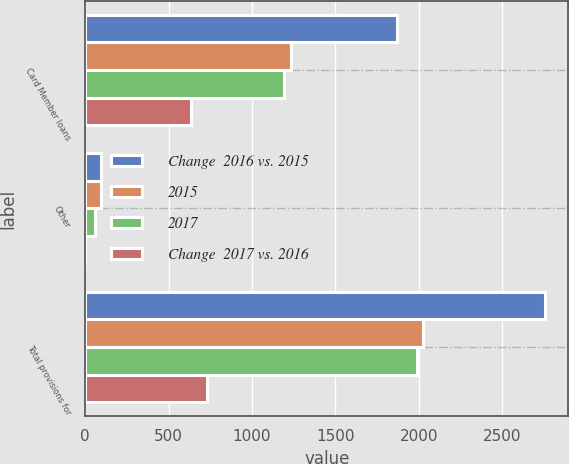<chart> <loc_0><loc_0><loc_500><loc_500><stacked_bar_chart><ecel><fcel>Card Member loans<fcel>Other<fcel>Total provisions for<nl><fcel>Change  2016 vs. 2015<fcel>1868<fcel>96<fcel>2759<nl><fcel>2015<fcel>1235<fcel>95<fcel>2026<nl><fcel>2017<fcel>1190<fcel>61<fcel>1988<nl><fcel>Change  2017 vs. 2016<fcel>633<fcel>1<fcel>733<nl></chart> 